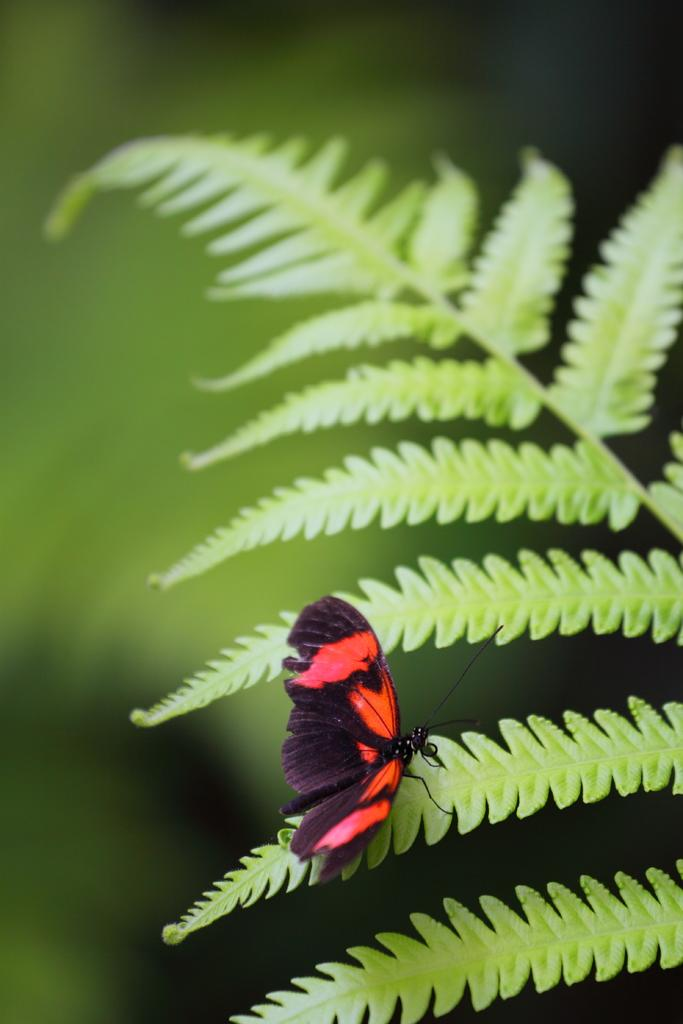What type of living organism can be seen in the image? There is a plant in the image. What other living organism can be seen in the image? There is a butterfly in the image. Can you describe the background of the image? The background of the image is blurred. What type of straw can be seen in the image? There is no straw present in the image. What time of day is depicted in the image? The time of day is not specified in the image, but the presence of a butterfly suggests it could be during the day. 